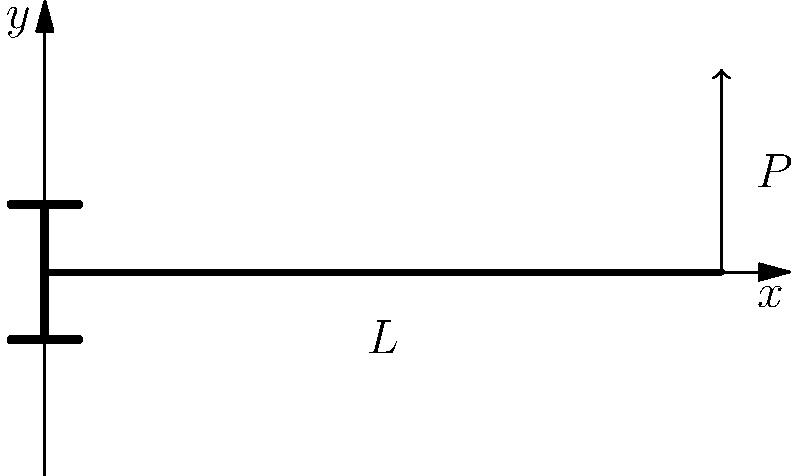A cantilever beam of length $L$ is fixed at one end and has a point load $P$ applied at its free end, as shown in the figure. Without using any gambling analogies, can you determine the general expressions for the shear force $V(x)$ and bending moment $M(x)$ at any point $x$ along the beam's length? Let's approach this step-by-step:

1) First, let's consider the shear force $V(x)$:
   - The shear force is constant along the beam's length.
   - It's equal to the applied load $P$, but in the opposite direction.
   - Therefore, $V(x) = -P$ for all $x$ from 0 to $L$.

2) Now, let's consider the bending moment $M(x)$:
   - The bending moment varies along the beam's length.
   - At any point $x$, the moment is equal to the force multiplied by the distance from that point to the point of application of the force.
   - The distance from any point $x$ to the free end is $(L-x)$.
   - Therefore, $M(x) = P(L-x)$.

3) Note that:
   - At the fixed end $(x=0)$, the moment is maximum: $M(0) = PL$.
   - At the free end $(x=L)$, the moment is zero: $M(L) = 0$.

4) The negative sign in the shear force equation and the positive sign in the moment equation are due to the sign convention typically used in beam analysis, where upward forces and counterclockwise moments are considered positive.
Answer: $V(x) = -P$, $M(x) = P(L-x)$ 